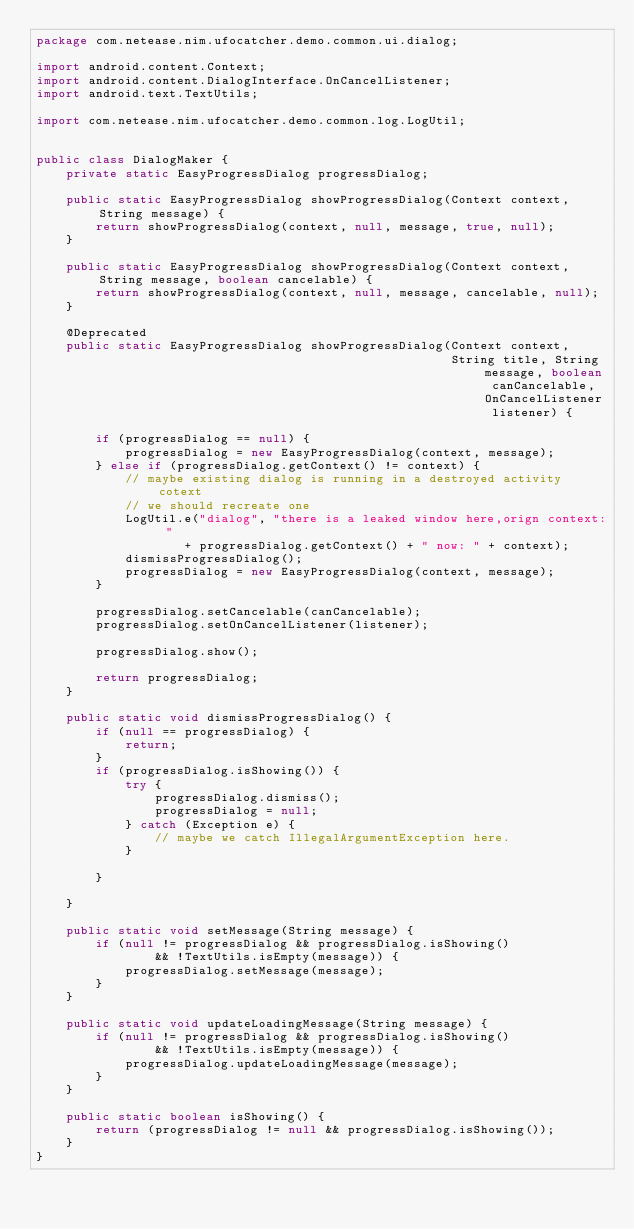Convert code to text. <code><loc_0><loc_0><loc_500><loc_500><_Java_>package com.netease.nim.ufocatcher.demo.common.ui.dialog;

import android.content.Context;
import android.content.DialogInterface.OnCancelListener;
import android.text.TextUtils;

import com.netease.nim.ufocatcher.demo.common.log.LogUtil;


public class DialogMaker {
    private static EasyProgressDialog progressDialog;

    public static EasyProgressDialog showProgressDialog(Context context, String message) {
        return showProgressDialog(context, null, message, true, null);
    }

    public static EasyProgressDialog showProgressDialog(Context context, String message, boolean cancelable) {
        return showProgressDialog(context, null, message, cancelable, null);
    }

    @Deprecated
    public static EasyProgressDialog showProgressDialog(Context context,
                                                        String title, String message, boolean canCancelable, OnCancelListener listener) {

        if (progressDialog == null) {
            progressDialog = new EasyProgressDialog(context, message);
        } else if (progressDialog.getContext() != context) {
            // maybe existing dialog is running in a destroyed activity cotext
            // we should recreate one
            LogUtil.e("dialog", "there is a leaked window here,orign context: "
                    + progressDialog.getContext() + " now: " + context);
            dismissProgressDialog();
            progressDialog = new EasyProgressDialog(context, message);
        }

        progressDialog.setCancelable(canCancelable);
        progressDialog.setOnCancelListener(listener);

        progressDialog.show();

        return progressDialog;
    }

    public static void dismissProgressDialog() {
        if (null == progressDialog) {
            return;
        }
        if (progressDialog.isShowing()) {
            try {
                progressDialog.dismiss();
                progressDialog = null;
            } catch (Exception e) {
                // maybe we catch IllegalArgumentException here.
            }

        }

    }

    public static void setMessage(String message) {
        if (null != progressDialog && progressDialog.isShowing()
                && !TextUtils.isEmpty(message)) {
            progressDialog.setMessage(message);
        }
    }

    public static void updateLoadingMessage(String message) {
        if (null != progressDialog && progressDialog.isShowing()
                && !TextUtils.isEmpty(message)) {
            progressDialog.updateLoadingMessage(message);
        }
    }

    public static boolean isShowing() {
        return (progressDialog != null && progressDialog.isShowing());
    }
}
</code> 